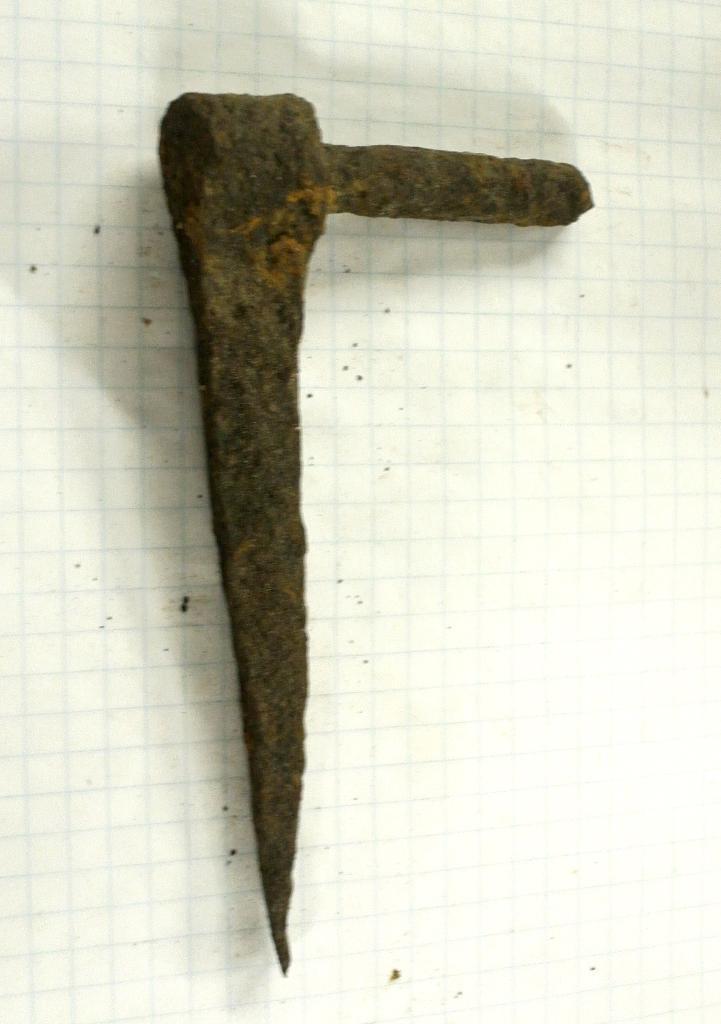Could you give a brief overview of what you see in this image? In this image we can see a tool placed on the surface. 